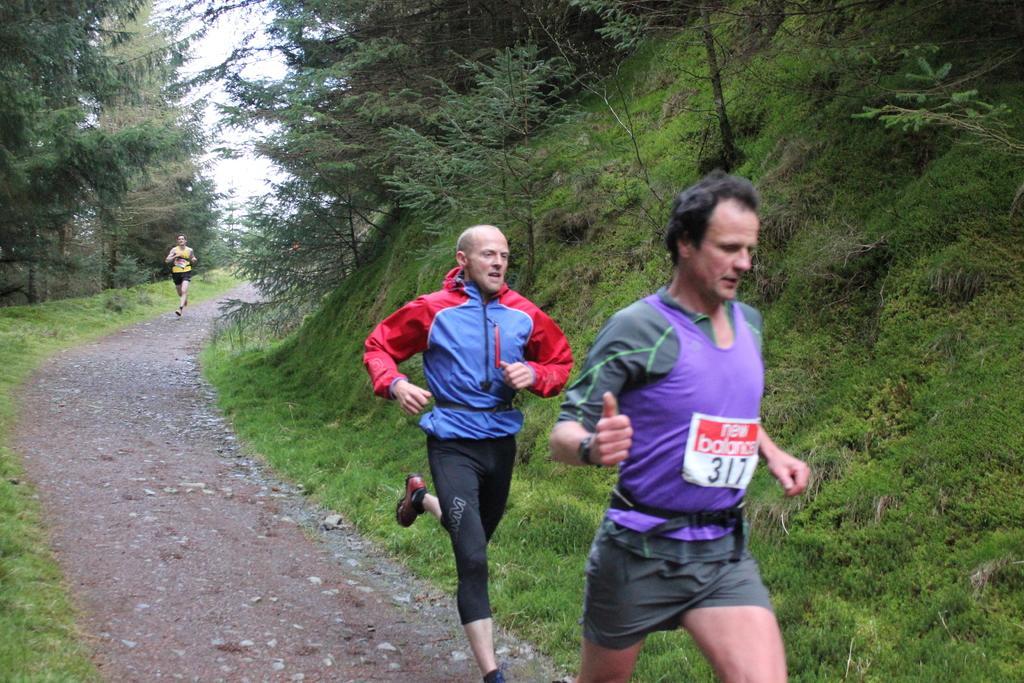Could you give a brief overview of what you see in this image? In this picture there are three persons running in a way and there are trees and a greenery ground on either sides of them. 